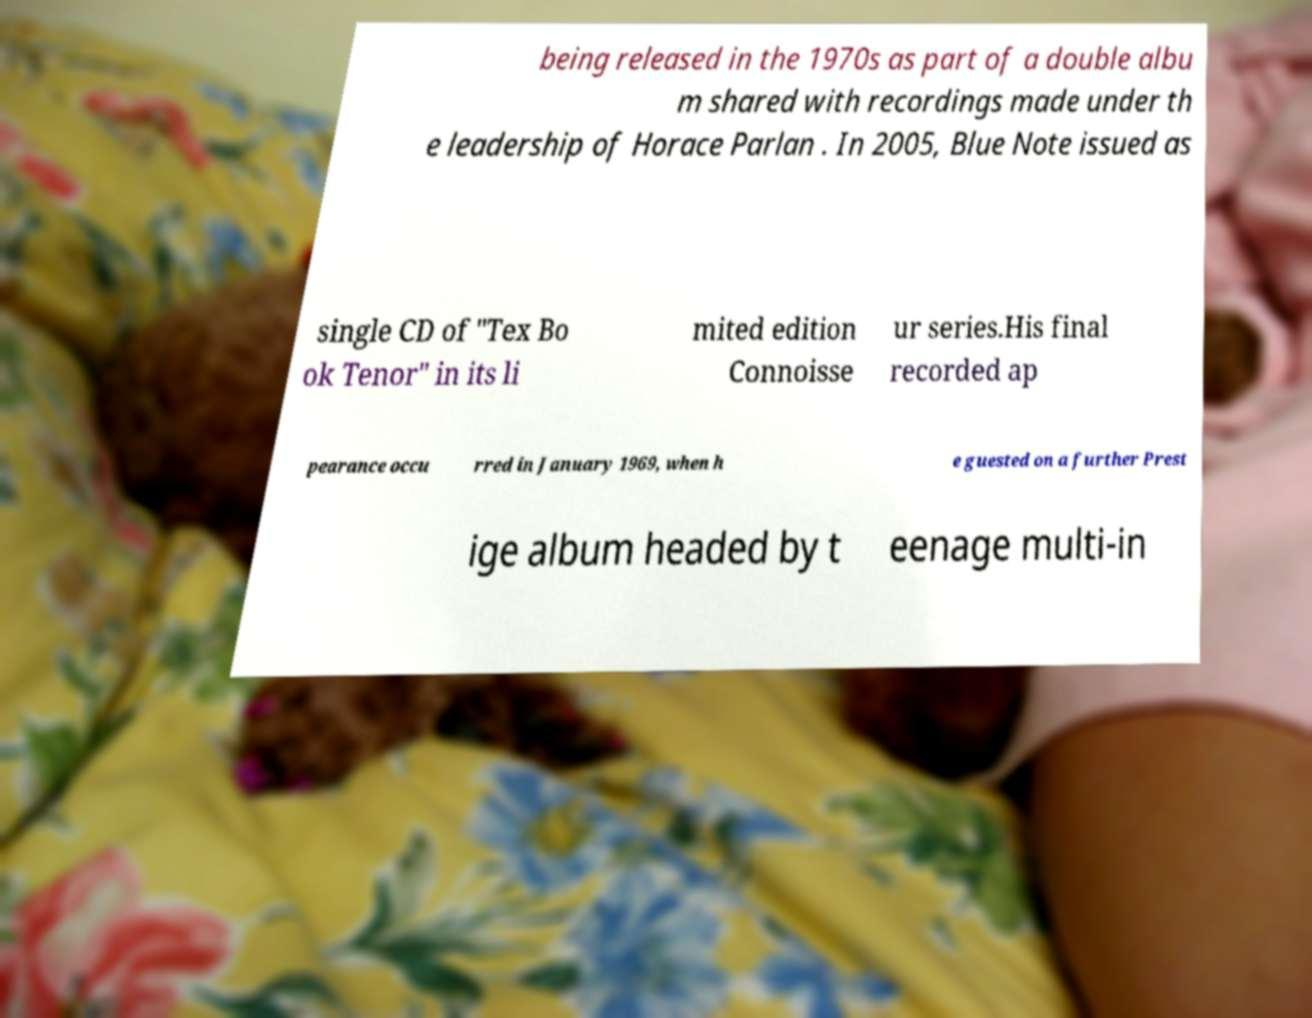Can you accurately transcribe the text from the provided image for me? being released in the 1970s as part of a double albu m shared with recordings made under th e leadership of Horace Parlan . In 2005, Blue Note issued as single CD of "Tex Bo ok Tenor" in its li mited edition Connoisse ur series.His final recorded ap pearance occu rred in January 1969, when h e guested on a further Prest ige album headed by t eenage multi-in 